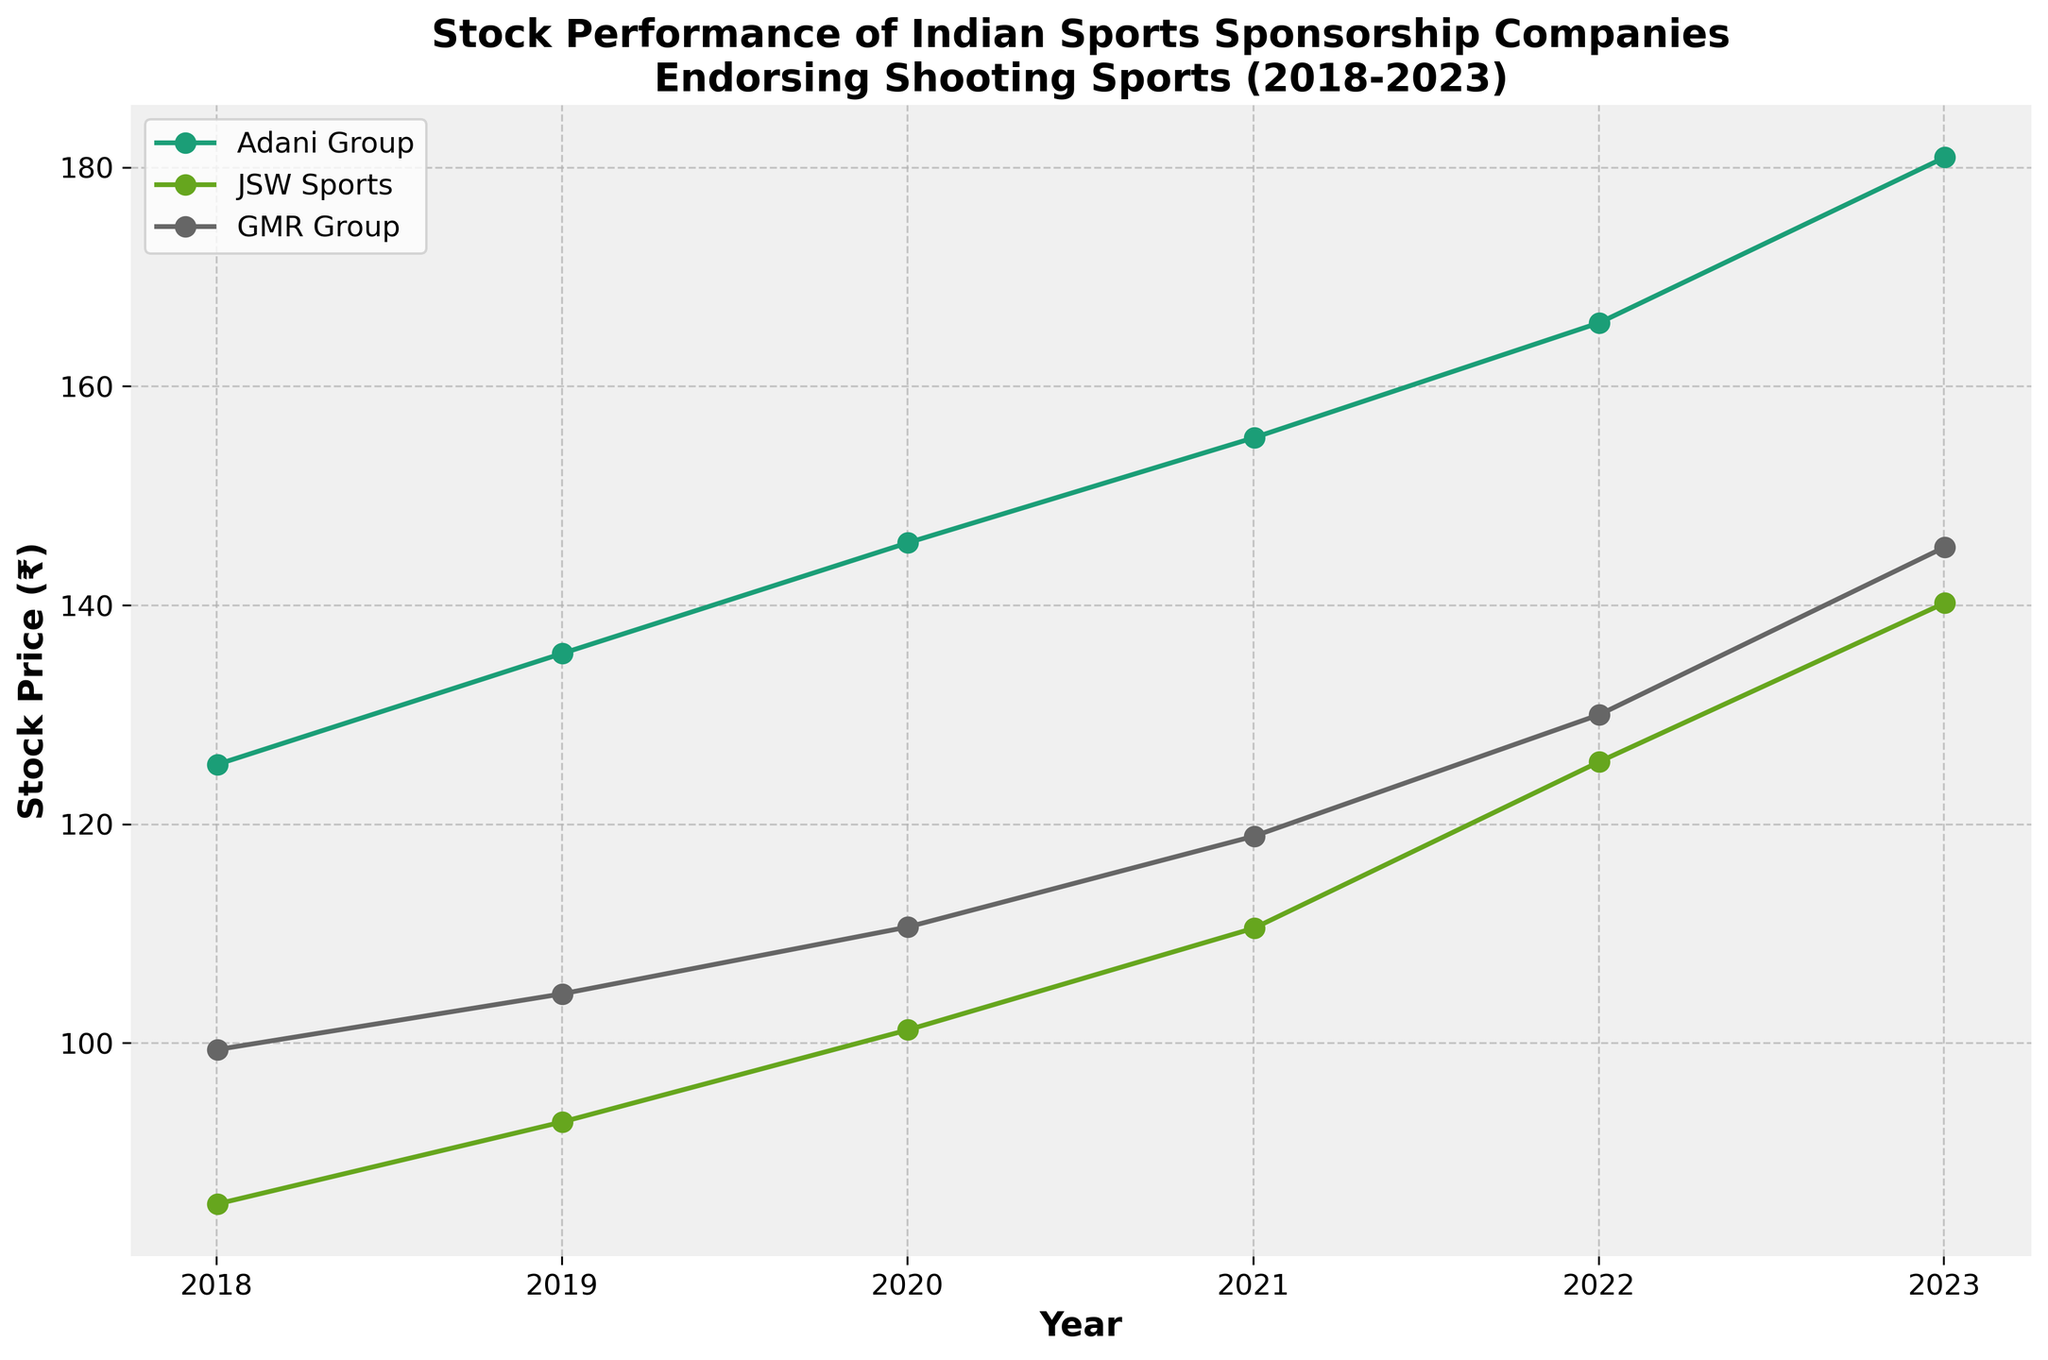what is the title of the stock price plot? The title of a plot is usually displayed at the top of the graph in larger font to summarize what the plot represents. From the description, the title should reflect the performance of Indian sports sponsorship companies endorsing shooting sports over a specific period.
Answer: "Stock Performance of Indian Sports Sponsorship Companies Endorsing Shooting Sports (2018-2023)" what are the labels of the x and y axes? The x-axis and y-axis labels provide information about what each axis represents in the graph. In this case, the x-axis likely represents "Year" and the y-axis represents "Stock Price (₹)".
Answer: "Year" (x-axis), "Stock Price (₹)" (y-axis) which company had the highest stock price in 2023? To determine this, look at the stock price values for each company in the year 2023 and identify which one is the highest. According to the data provided, Adani Group had a stock price of ₹180.90 in 2023, which is higher than the others.
Answer: Adani Group how many data points are there for each company? To find the number of data points, count the number of stock prices recorded for each company from 2018 to 2023. For each company (Adani Group, JSW Sports, GMR Group), there are six data points, one for each year (2018-2023).
Answer: 6 data points per company what is the general trend of JSW Sports' stock price from 2018 to 2023? To identify the trend, observe the stock prices of JSW Sports over the years. JSW Sports' stock price increased steadily from 85.30 in 2018 to 140.20 in 2023.
Answer: Increasing trend which company showed the most overall growth in stock price from 2018 to 2023? We need to calculate the difference between the stock price in 2023 and 2018 for each company. The difference is largest for Adani Group (180.90 - 125.45 = 55.45), indicating the most overall growth.
Answer: Adani Group what was the stock price increase for GMR Group from 2020 to 2021? To find this, subtract the stock price of GMR Group in 2020 from its stock price in 2021. So, 118.90 (2021) - 110.60 (2020) = 8.3.
Answer: ₹8.3 compare the stock price of Adani Group in 2022 and 2023. Is there an increase or decrease and by how much? By comparing the stock prices of Adani Group in 2022 and 2023: ₹180.90 (2023) - ₹165.80 (2022) = ₹15.10 increase.
Answer: Increase by ₹15.10 